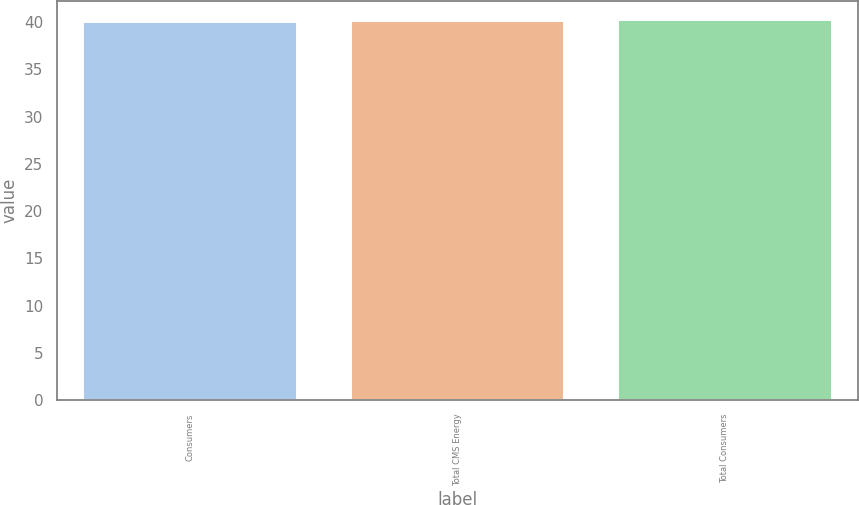Convert chart to OTSL. <chart><loc_0><loc_0><loc_500><loc_500><bar_chart><fcel>Consumers<fcel>Total CMS Energy<fcel>Total Consumers<nl><fcel>40<fcel>40.1<fcel>40.2<nl></chart> 